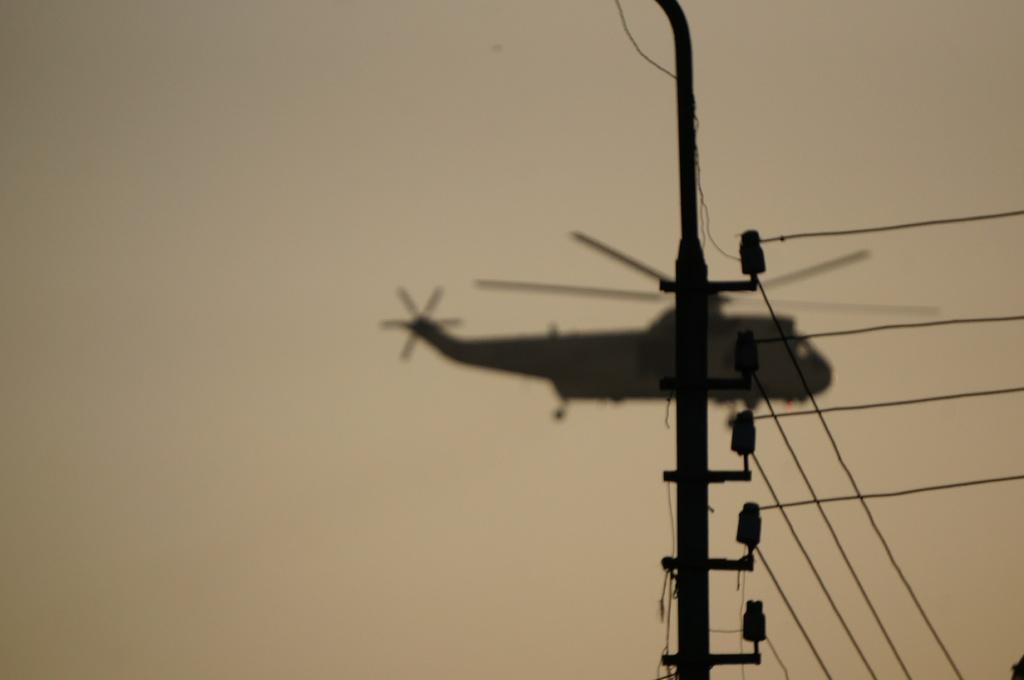What is the main structure visible in the image? There is a pole in the image. What else can be seen in the image besides the pole? There are wires and some objects visible in the image. Can you describe the helicopter in the image? There is a helicopter flying in the sky in the background of the image. What type of flower can be seen growing near the pole in the image? There are no flowers visible in the image; it only features a pole, wires, objects, and a helicopter in the background. 